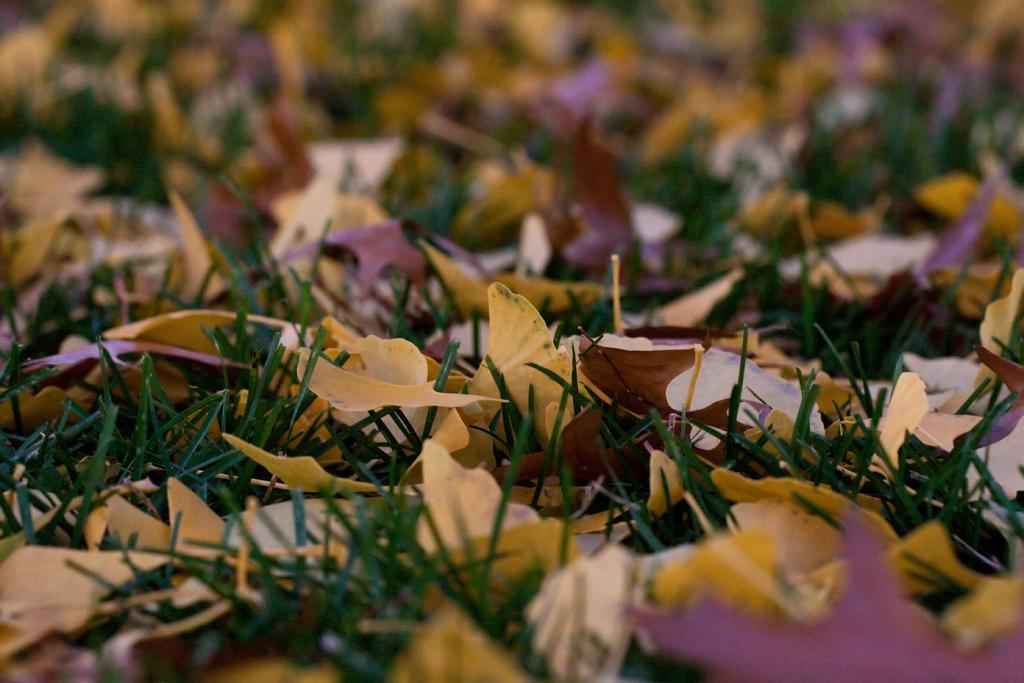What is covering the grass in the image? There are dry leaves on the grass in the image. Can you describe any other features of the image? A part of the image is blurred. What type of game is being played on the sofa in the image? There is no sofa or game present in the image; it only features dry leaves on the grass and a blurred part. 